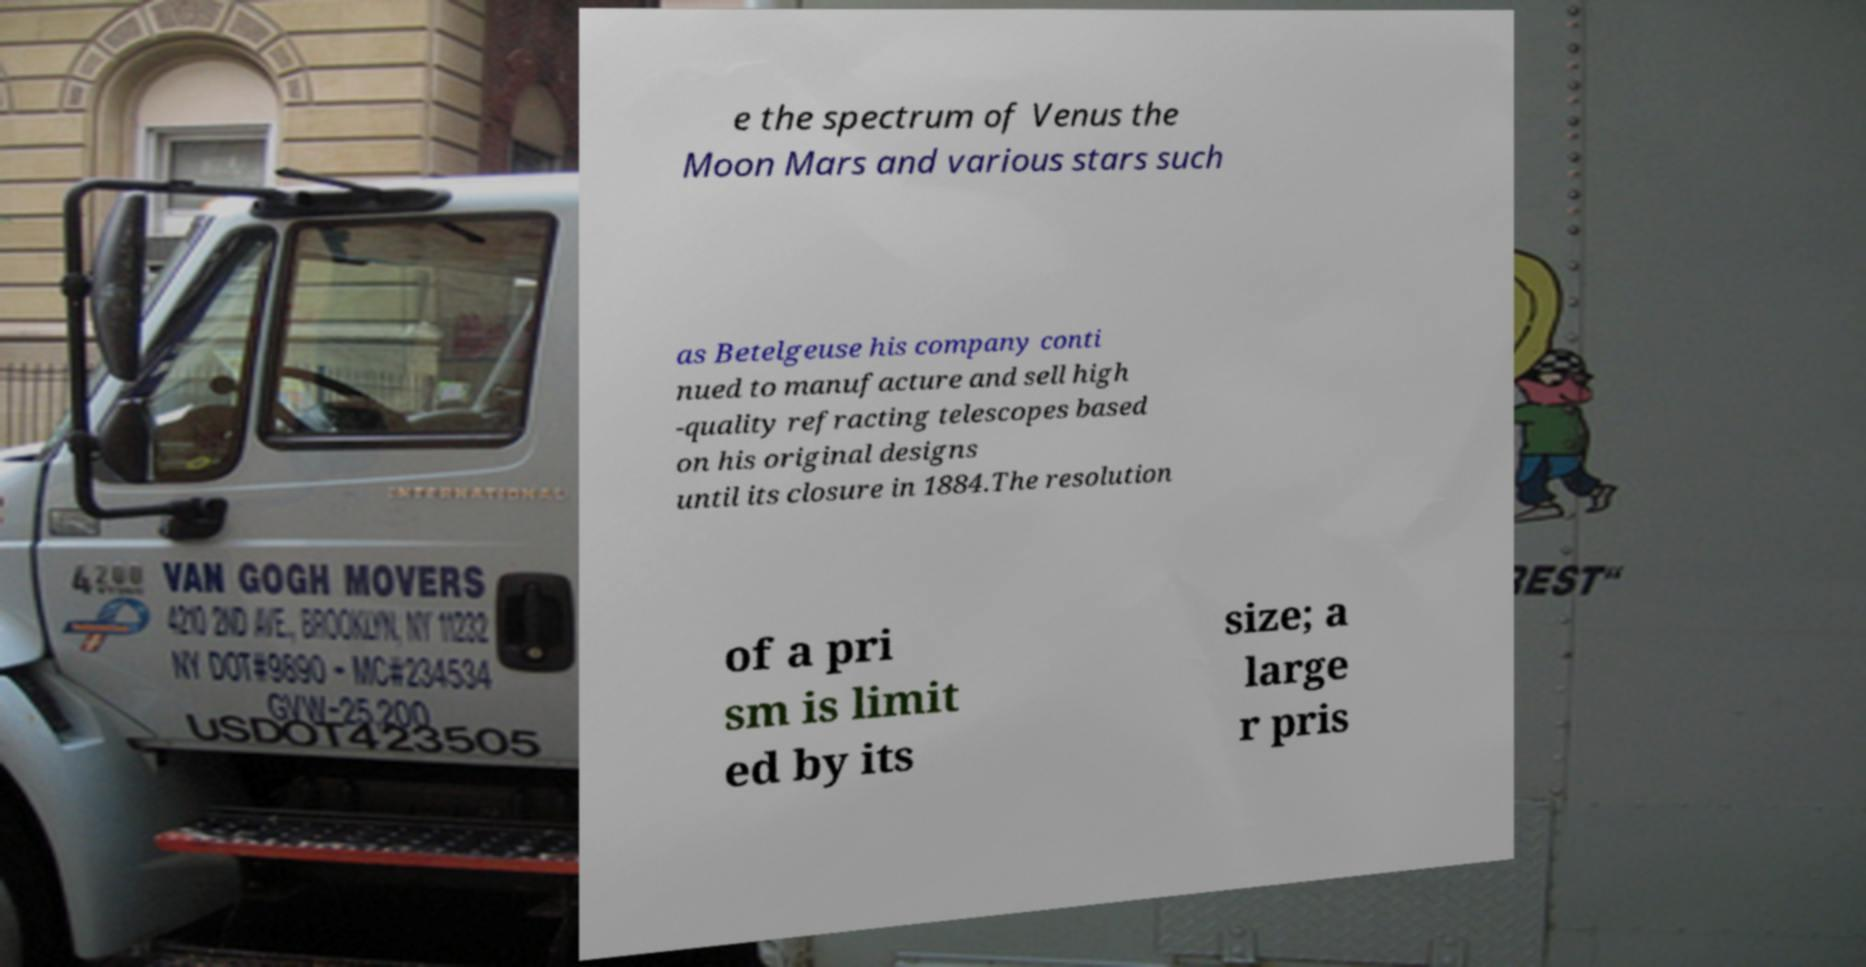Please identify and transcribe the text found in this image. e the spectrum of Venus the Moon Mars and various stars such as Betelgeuse his company conti nued to manufacture and sell high -quality refracting telescopes based on his original designs until its closure in 1884.The resolution of a pri sm is limit ed by its size; a large r pris 